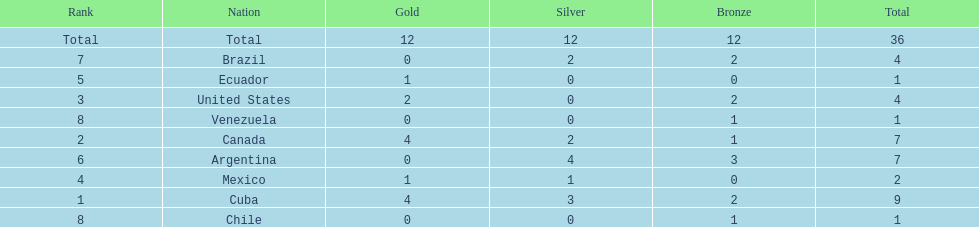Which is the only nation to win a gold medal and nothing else? Ecuador. Parse the table in full. {'header': ['Rank', 'Nation', 'Gold', 'Silver', 'Bronze', 'Total'], 'rows': [['Total', 'Total', '12', '12', '12', '36'], ['7', 'Brazil', '0', '2', '2', '4'], ['5', 'Ecuador', '1', '0', '0', '1'], ['3', 'United States', '2', '0', '2', '4'], ['8', 'Venezuela', '0', '0', '1', '1'], ['2', 'Canada', '4', '2', '1', '7'], ['6', 'Argentina', '0', '4', '3', '7'], ['4', 'Mexico', '1', '1', '0', '2'], ['1', 'Cuba', '4', '3', '2', '9'], ['8', 'Chile', '0', '0', '1', '1']]} 